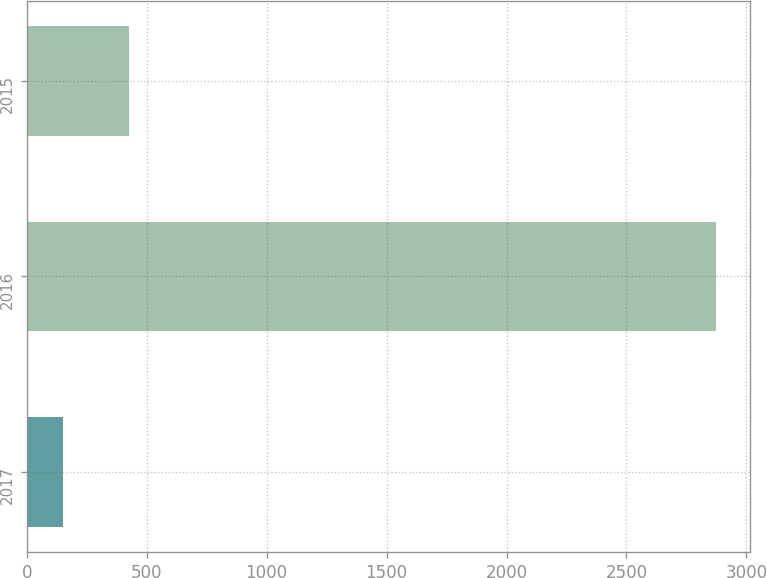Convert chart. <chart><loc_0><loc_0><loc_500><loc_500><bar_chart><fcel>2017<fcel>2016<fcel>2015<nl><fcel>152<fcel>2872<fcel>424<nl></chart> 